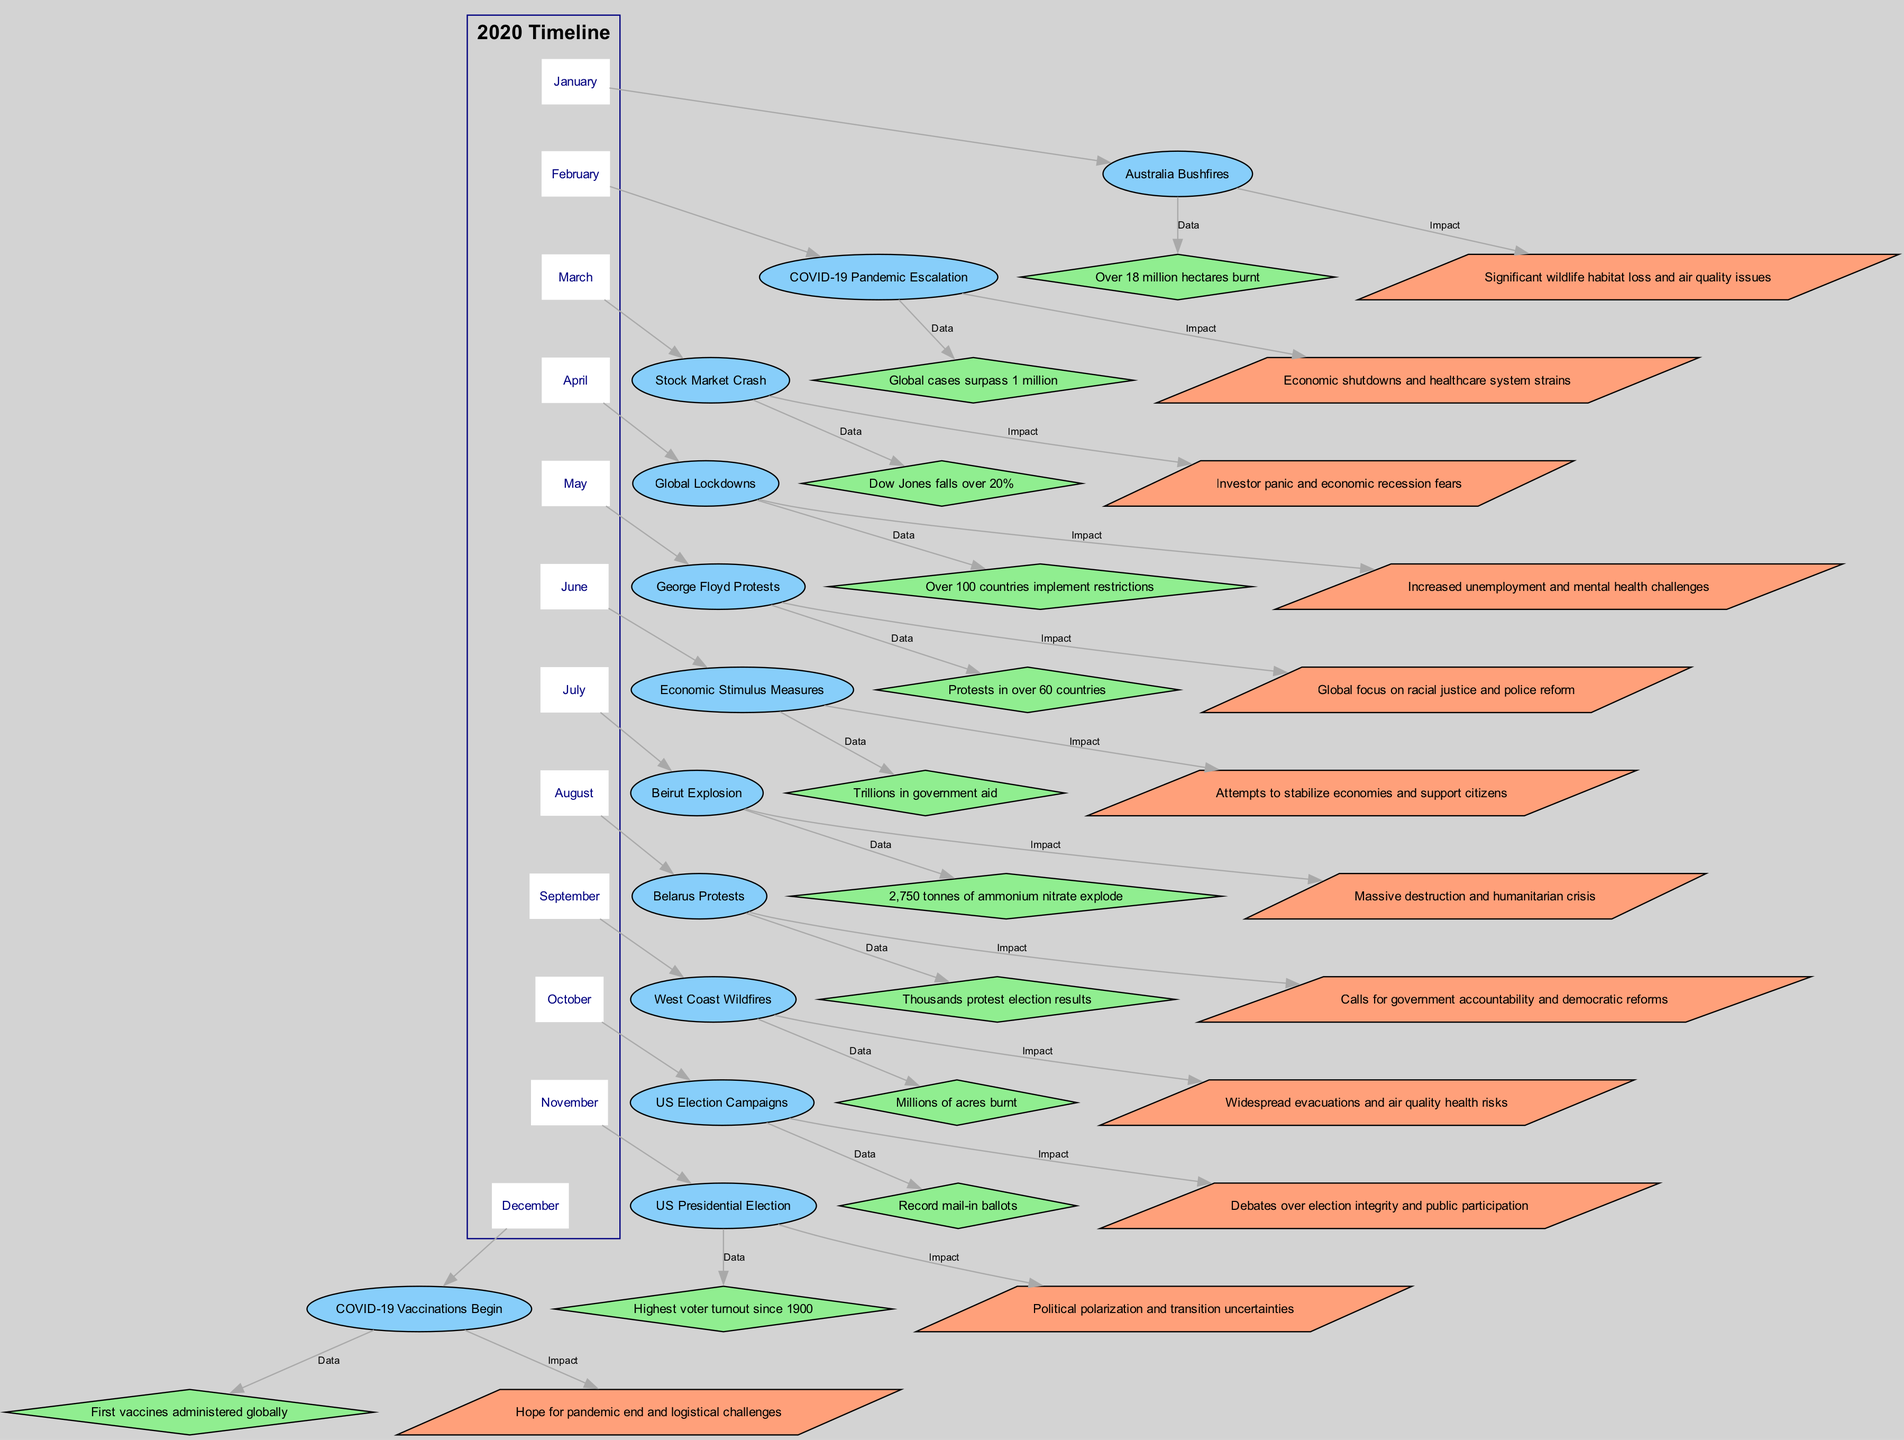What event occurred in March? By examining the March section of the diagram, we find that the node labeled 'March_event' contains the text "Stock Market Crash".
Answer: Stock Market Crash How many countries implemented restrictions in April? Looking at the 'April_data' node, it states "Over 100 countries implement restrictions", which gives us the number of countries involved.
Answer: Over 100 What data point is associated with the George Floyd protests in May? Referencing the May section, the 'May_data' node provides the information "Protests in over 60 countries", indicating the scale of the protests.
Answer: Protests in over 60 countries What was the key impact of the Lebanon explosion in July? In July's section, the 'July_impact' node indicates "Massive destruction and humanitarian crisis", summarizing the main outcomes of the event.
Answer: Massive destruction and humanitarian crisis Which month had the highest voter turnout since 1900? By checking November's section, the 'November_data' node states "Highest voter turnout since 1900", directly answering the question.
Answer: Highest voter turnout since 1900 What trend can be observed between the June Economic Stimulus Measures and the following months? The connection from June shows "Trillions in government aid", suggesting that economic measures influence events in subsequent months, such as heightened protests and election-related activities.
Answer: Economic influence on subsequent events What event led to calls for government accountability in August? The August section's 'August_event' node specifies "Belarus Protests", which were directly related to demands for government accountability.
Answer: Belarus Protests Which month's data indicates over 18 million hectares burnt? The January section's 'January_data' notes "Over 18 million hectares burnt", accurately providing the data point.
Answer: Over 18 million hectares burnt What was a significant impact of the COVID-19 Pandemic escalation in February? The 'February_impact' node states "Economic shutdowns and healthcare system strains", reflecting the pandemic's serious consequences in that month.
Answer: Economic shutdowns and healthcare system strains 